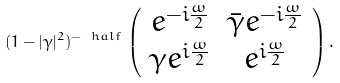<formula> <loc_0><loc_0><loc_500><loc_500>( 1 - | \gamma | ^ { 2 } ) ^ { - \ h a l f } \, \left ( \begin{array} { c c } e ^ { - i \frac { \omega } { 2 } } & \bar { \gamma } e ^ { - i \frac { \omega } { 2 } } \\ { \gamma } e ^ { i \frac { \omega } { 2 } } & e ^ { i \frac { \omega } { 2 } } \end{array} \right ) .</formula> 